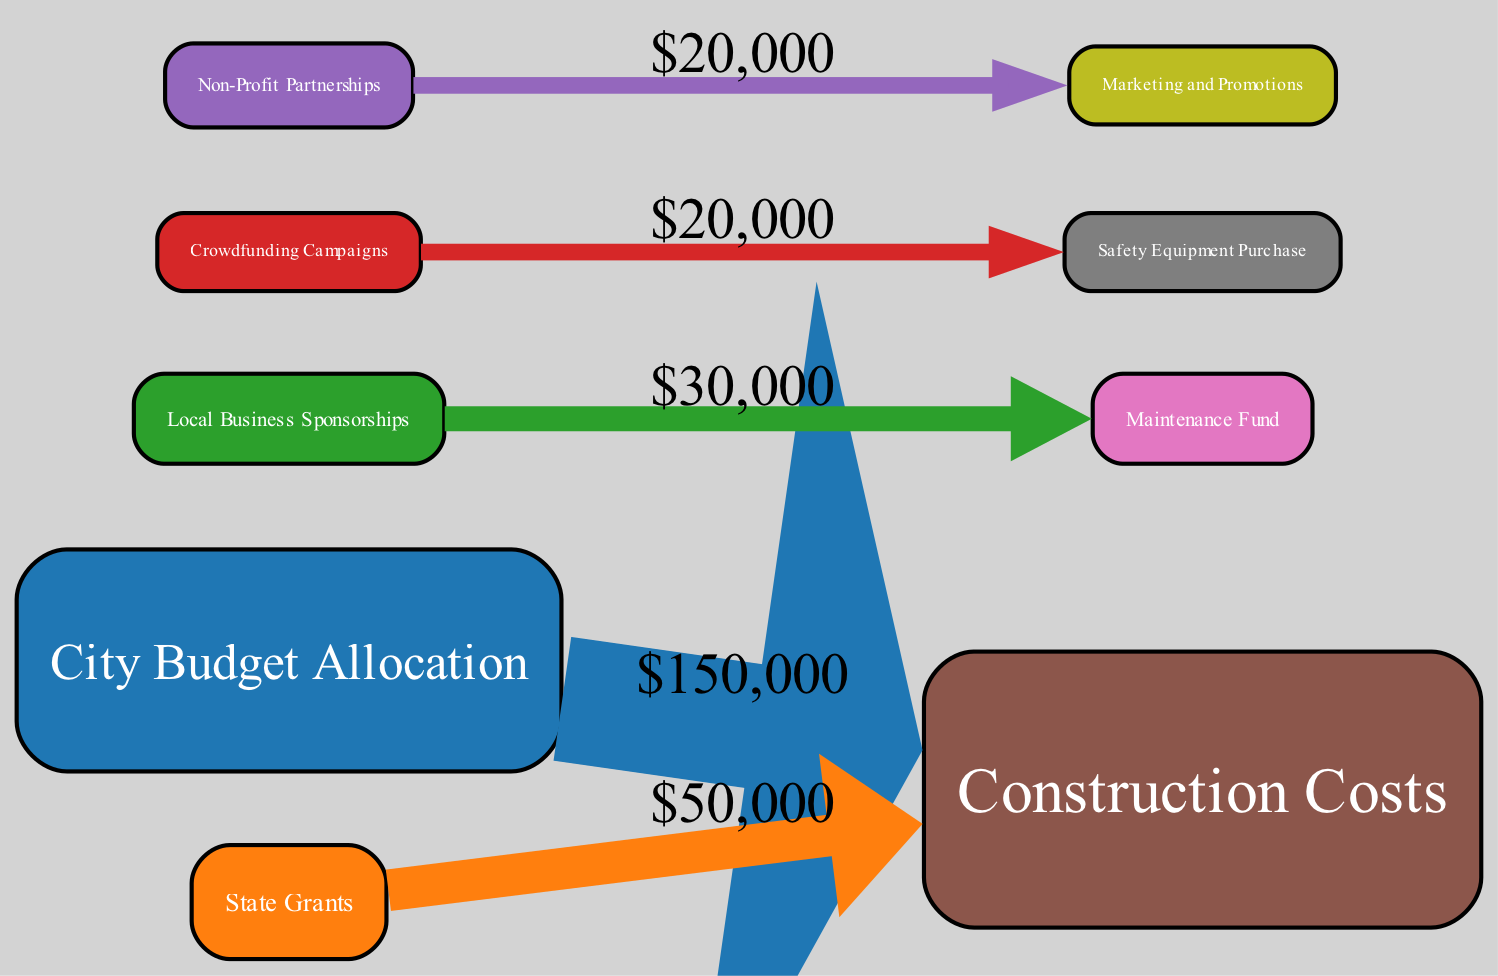What is the total budget allocated for the skate park project? The total budget is calculated by summing up all sources: City Budget Allocation ($150,000) + State Grants ($50,000) + Local Business Sponsorships ($30,000) + Crowdfunding Campaigns ($20,000) + Non-Profit Partnerships ($25,000) = $275,000.
Answer: 275000 How much funding comes from local business sponsorships? The diagram specifies that Local Business Sponsorships contribute $30,000 to the project.
Answer: 30000 What is the highest allocation category? By comparing the allocation amounts, Construction Costs ($200,000) is the highest when compared to Maintenance Fund ($30,000), Safety Equipment Purchase ($20,000), and Marketing and Promotions ($20,000).
Answer: 200000 Which funding source contributes the least amount? Upon reviewing the sources, Crowdfunding Campaigns contribute the least at $20,000 when compared to the other sources listed.
Answer: 20000 What proportion of the total budget is allocated to marketing and promotions? Marketing and Promotions receive $20,000 out of a total budget of $275,000, calculated as $20,000 / $275,000. This yields approximately 0.0727, or 7.27% when expressed as a percentage.
Answer: 7.27% How is the funding for maintenance derived from the sources? Analyzing the flow, the Maintenance Fund of $30,000 is funded directly by the remaining amounts from various sources. The diagram indicates that this fund flows from the sources, specifically affecting the available budgets as shown in the diagram edges.
Answer: From multiple sources Which source contributed the most to construction costs? The Construction Costs of $200,000 are primarily supported by the City Budget Allocation of $150,000, along with contributions from State Grants and the others, but the largest individual source is the City Budget Allocation.
Answer: City Budget Allocation What portion of the total funding is allocated to safety equipment purchase? The Safety Equipment Purchase category receives $20,000, amounting to $20,000 out of a total budget of $275,000, resulting in approximately 0.0727, or 7.27% when expressed as a percentage.
Answer: 7.27% What is the total amount contributed by public sources? The combined total for public sources consists of City Budget Allocation ($150,000) and State Grants ($50,000), which totals to $200,000.
Answer: 200000 Which allocation has no contributions from crowdfunding? The diagram clearly shows that both Construction Costs ($200,000) and Maintenance Fund ($30,000) do not have any contributions from Crowdfunding Campaigns, as they flow from other sources instead.
Answer: Maintenance Fund 